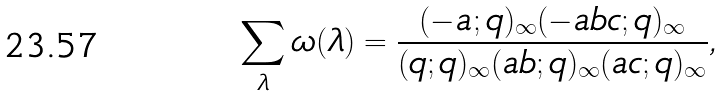Convert formula to latex. <formula><loc_0><loc_0><loc_500><loc_500>\sum _ { \lambda } \omega ( \lambda ) = \frac { ( - a ; q ) _ { \infty } ( - a b c ; q ) _ { \infty } } { ( q ; q ) _ { \infty } ( a b ; q ) _ { \infty } ( a c ; q ) _ { \infty } } ,</formula> 